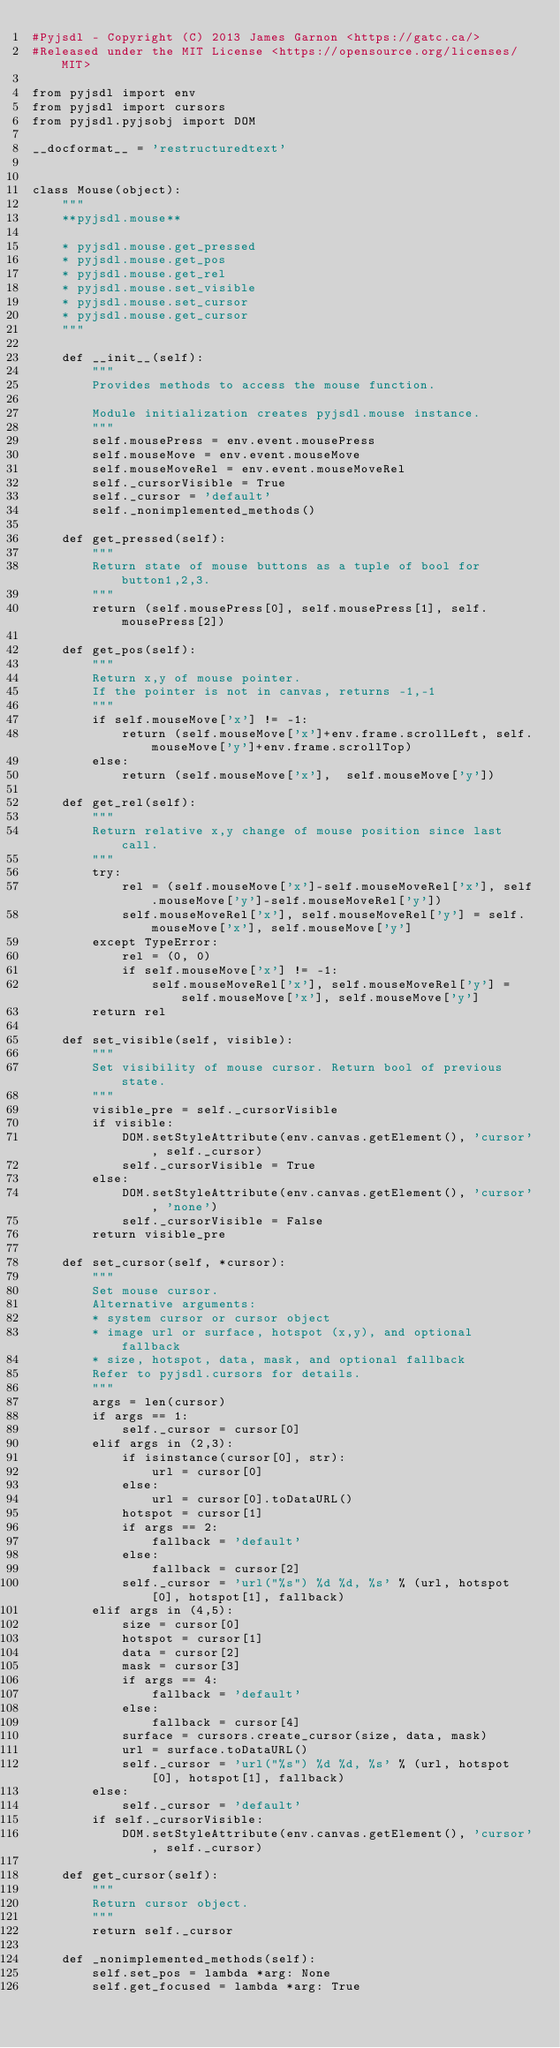Convert code to text. <code><loc_0><loc_0><loc_500><loc_500><_Python_>#Pyjsdl - Copyright (C) 2013 James Garnon <https://gatc.ca/>
#Released under the MIT License <https://opensource.org/licenses/MIT>

from pyjsdl import env
from pyjsdl import cursors
from pyjsdl.pyjsobj import DOM

__docformat__ = 'restructuredtext'


class Mouse(object):
    """
    **pyjsdl.mouse**
    
    * pyjsdl.mouse.get_pressed
    * pyjsdl.mouse.get_pos
    * pyjsdl.mouse.get_rel
    * pyjsdl.mouse.set_visible
    * pyjsdl.mouse.set_cursor
    * pyjsdl.mouse.get_cursor
    """

    def __init__(self):
        """
        Provides methods to access the mouse function.
        
        Module initialization creates pyjsdl.mouse instance.
        """
        self.mousePress = env.event.mousePress
        self.mouseMove = env.event.mouseMove
        self.mouseMoveRel = env.event.mouseMoveRel
        self._cursorVisible = True
        self._cursor = 'default'
        self._nonimplemented_methods()

    def get_pressed(self):
        """
        Return state of mouse buttons as a tuple of bool for button1,2,3.
        """
        return (self.mousePress[0], self.mousePress[1], self.mousePress[2])

    def get_pos(self):
        """
        Return x,y of mouse pointer.
        If the pointer is not in canvas, returns -1,-1
        """
        if self.mouseMove['x'] != -1:
            return (self.mouseMove['x']+env.frame.scrollLeft, self.mouseMove['y']+env.frame.scrollTop)
        else:
            return (self.mouseMove['x'],  self.mouseMove['y'])

    def get_rel(self):
        """
        Return relative x,y change of mouse position since last call.
        """
        try:
            rel = (self.mouseMove['x']-self.mouseMoveRel['x'], self.mouseMove['y']-self.mouseMoveRel['y'])
            self.mouseMoveRel['x'], self.mouseMoveRel['y'] = self.mouseMove['x'], self.mouseMove['y']
        except TypeError:
            rel = (0, 0)
            if self.mouseMove['x'] != -1:
                self.mouseMoveRel['x'], self.mouseMoveRel['y'] = self.mouseMove['x'], self.mouseMove['y']
        return rel

    def set_visible(self, visible):
        """
        Set visibility of mouse cursor. Return bool of previous state.
        """
        visible_pre = self._cursorVisible
        if visible:
            DOM.setStyleAttribute(env.canvas.getElement(), 'cursor', self._cursor)
            self._cursorVisible = True
        else:
            DOM.setStyleAttribute(env.canvas.getElement(), 'cursor', 'none')
            self._cursorVisible = False
        return visible_pre

    def set_cursor(self, *cursor):
        """
        Set mouse cursor.
        Alternative arguments:
        * system cursor or cursor object
        * image url or surface, hotspot (x,y), and optional fallback
        * size, hotspot, data, mask, and optional fallback
        Refer to pyjsdl.cursors for details.
        """
        args = len(cursor)
        if args == 1:
            self._cursor = cursor[0]
        elif args in (2,3):
            if isinstance(cursor[0], str):
                url = cursor[0]
            else:
                url = cursor[0].toDataURL()
            hotspot = cursor[1]
            if args == 2:
                fallback = 'default'
            else:
                fallback = cursor[2]
            self._cursor = 'url("%s") %d %d, %s' % (url, hotspot[0], hotspot[1], fallback)
        elif args in (4,5):
            size = cursor[0]
            hotspot = cursor[1]
            data = cursor[2]
            mask = cursor[3]
            if args == 4:
                fallback = 'default'
            else:
                fallback = cursor[4]
            surface = cursors.create_cursor(size, data, mask)
            url = surface.toDataURL()
            self._cursor = 'url("%s") %d %d, %s' % (url, hotspot[0], hotspot[1], fallback)
        else:
            self._cursor = 'default'
        if self._cursorVisible:
            DOM.setStyleAttribute(env.canvas.getElement(), 'cursor', self._cursor)

    def get_cursor(self):
        """
        Return cursor object.
        """
        return self._cursor

    def _nonimplemented_methods(self):
        self.set_pos = lambda *arg: None
        self.get_focused = lambda *arg: True

</code> 